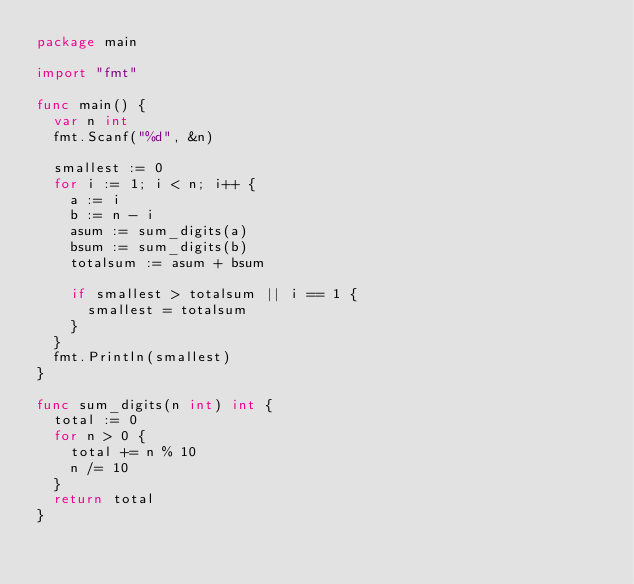Convert code to text. <code><loc_0><loc_0><loc_500><loc_500><_Go_>package main

import "fmt"

func main() {
	var n int
	fmt.Scanf("%d", &n)

	smallest := 0
	for i := 1; i < n; i++ {
		a := i
		b := n - i
		asum := sum_digits(a)
		bsum := sum_digits(b)
		totalsum := asum + bsum

		if smallest > totalsum || i == 1 {
			smallest = totalsum
		}
	}
	fmt.Println(smallest)
}

func sum_digits(n int) int {
	total := 0
	for n > 0 {
		total += n % 10
		n /= 10
	}
	return total
}
</code> 